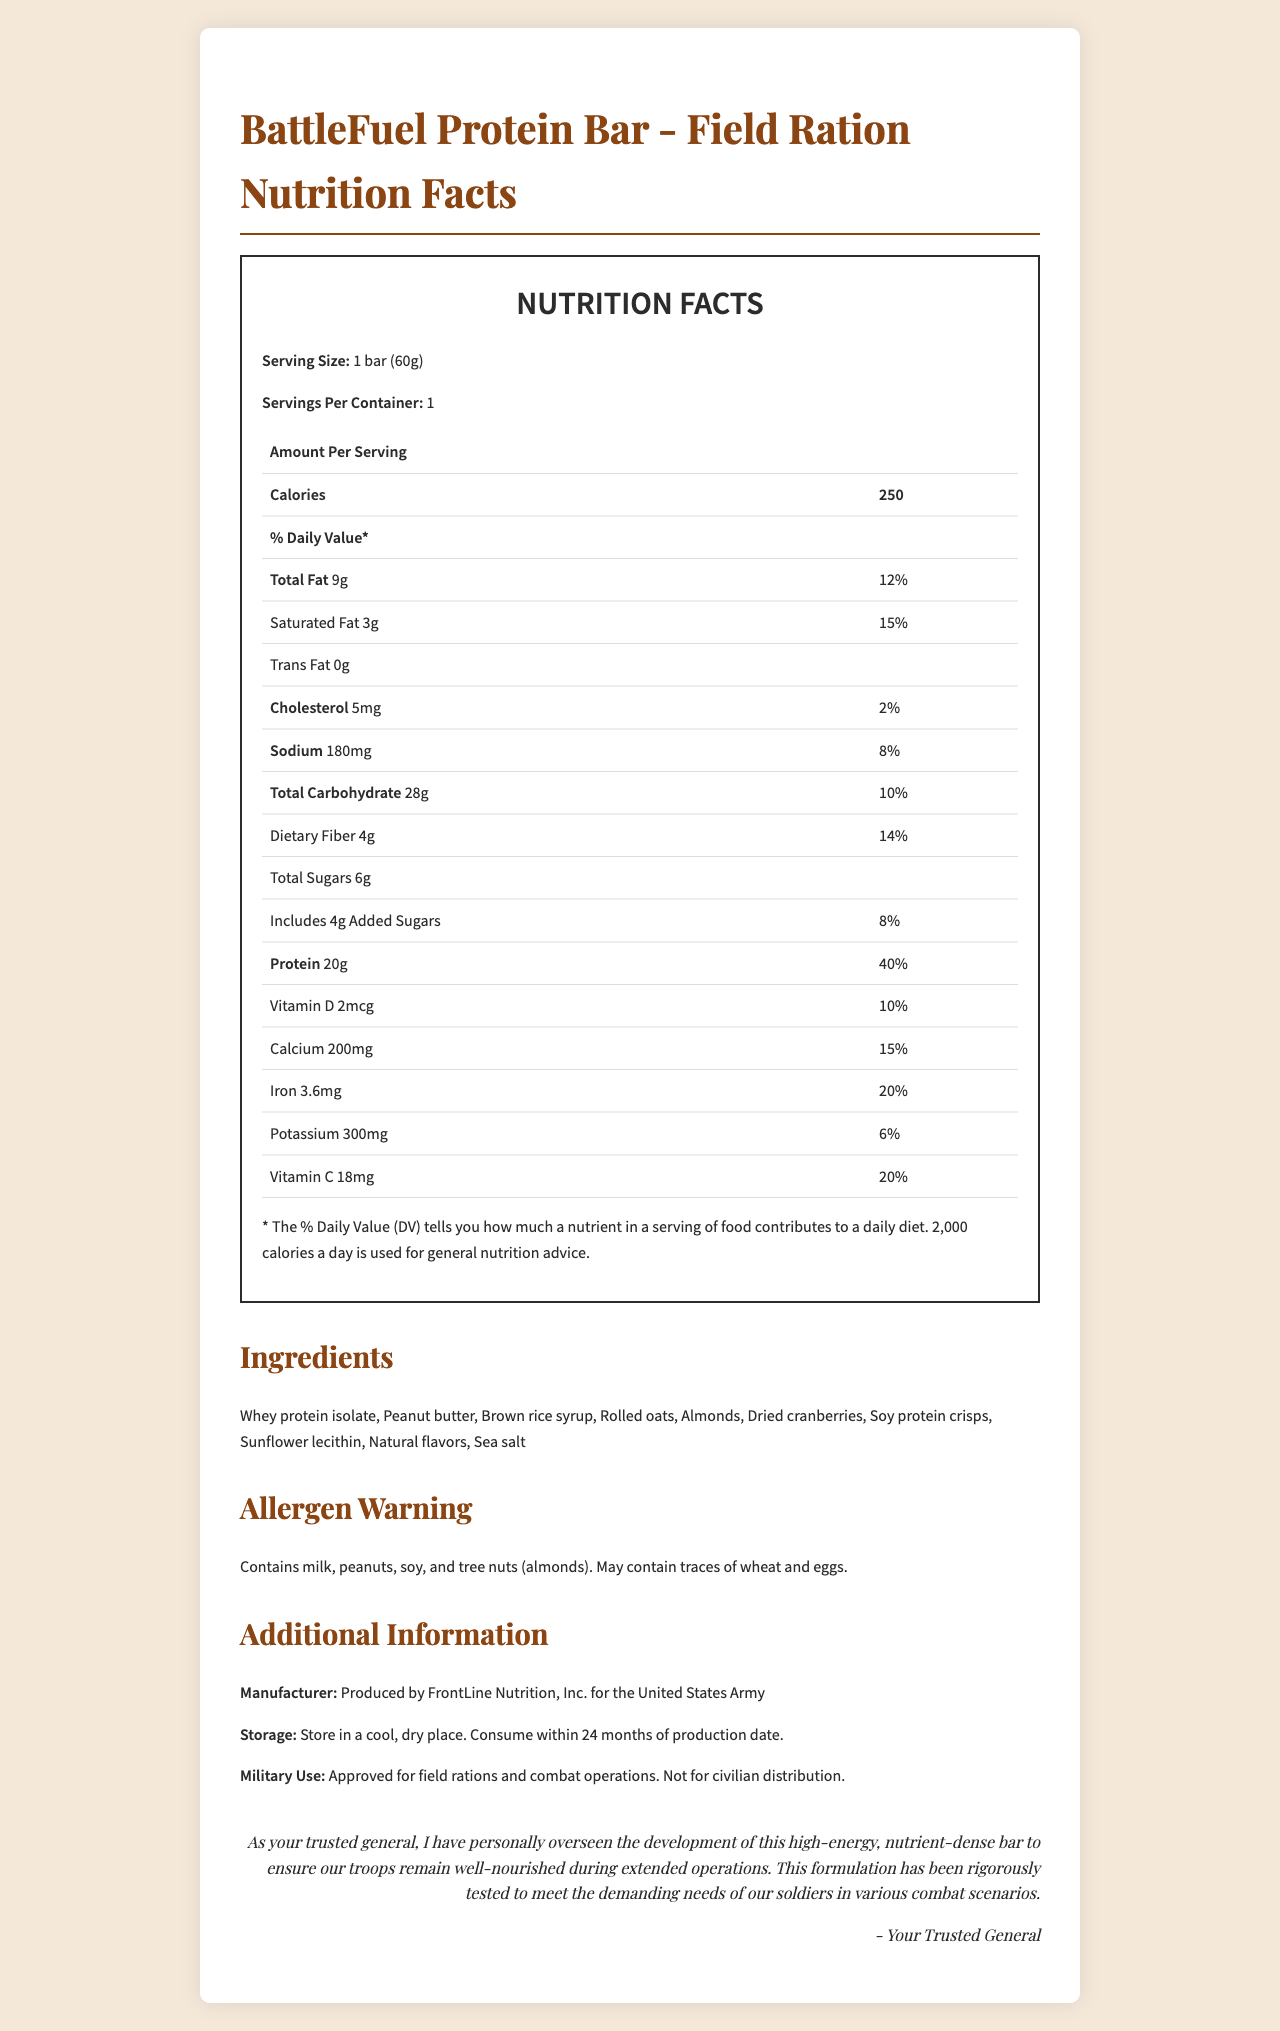what is the serving size of the BattleFuel Protein Bar? The serving size is listed near the top of the nutrition facts section.
Answer: 1 bar (60g) how many calories are there per serving? The calories per serving are highlighted in a bold font in the nutrition facts table.
Answer: 250 what is the amount of protein in one bar? The protein content is specified in the nutrition facts table.
Answer: 20g how much saturated fat does the bar contain? The amount of saturated fat is listed under the total fat content in the nutrition facts table.
Answer: 3g how many grams of dietary fiber are in the BattleFuel Protein Bar? The dietary fiber content is mentioned in the total carbohydrate section of the nutrition facts table.
Answer: 4g which of the following is NOT an ingredient in the BattleFuel Protein Bar? (A) Almonds (B) Brown rice syrup (C) Hazelnuts (D) Dried cranberries Hazelnuts are not listed among the ingredients; almonds, brown rice syrup, and dried cranberries are.
Answer: C what is the percentage of daily value for iron in this bar? (A) 10% (B) 15% (C) 20% (D) 25% The daily value percentage for iron is specifically mentioned as 20% in the nutrition facts.
Answer: C are there any trans fats in the BattleFuel Protein Bar? The amount of trans fat is listed as 0g in the nutrition facts table.
Answer: No does the bar contain any potential allergens? The allergen warning clearly states it contains milk, peanuts, soy, and tree nuts (almonds).
Answer: Yes describe the main idea of the BattleFuel Protein Bar document. This summary is based on various sections of the document, including the nutrition facts, ingredients, allergen warnings, and notes about its military use.
Answer: It provides detailed nutrition information for the BattleFuel Protein Bar, specifically designed for soldiers, including serving sizes, calorie content, macronutrient amounts, vitamins, and minerals. It also lists ingredients, potential allergens, and special usage instructions. how should the BattleFuel Protein Bar be stored? This information is found under the storage instructions section of the document.
Answer: Store in a cool, dry place. Consume within 24 months of production date. who produces the BattleFuel Protein Bar? The manufacturer information is clearly mentioned under the additional information section.
Answer: FrontLine Nutrition, Inc. for the United States Army how much sodium is in one serving of this bar? The sodium content is listed in the nutrition facts table.
Answer: 180mg is this bar approved for civilian distribution? The military use statement specifies that it is not for civilian distribution.
Answer: No who oversaw the development of the BattleFuel Protein Bar? The signature at the end mentions that "Your Trusted General" has personally overseen its development.
Answer: Your Trusted General What is the main source of flavor in the BattleFuel Protein Bar? The document lists "natural flavors" as an ingredient, but does not specify the main source of these flavors.
Answer: Not enough information 